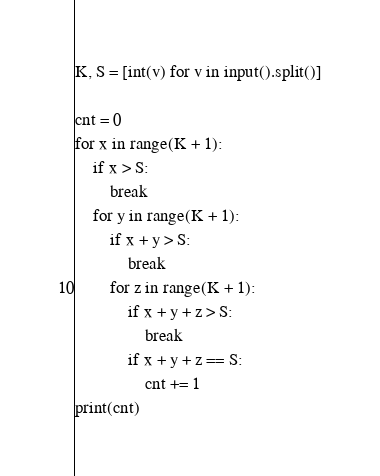Convert code to text. <code><loc_0><loc_0><loc_500><loc_500><_Python_>K, S = [int(v) for v in input().split()]

cnt = 0
for x in range(K + 1):
    if x > S:
        break
    for y in range(K + 1):
        if x + y > S:
            break
        for z in range(K + 1):
            if x + y + z > S:
                break
            if x + y + z == S:
                cnt += 1
print(cnt)
</code> 